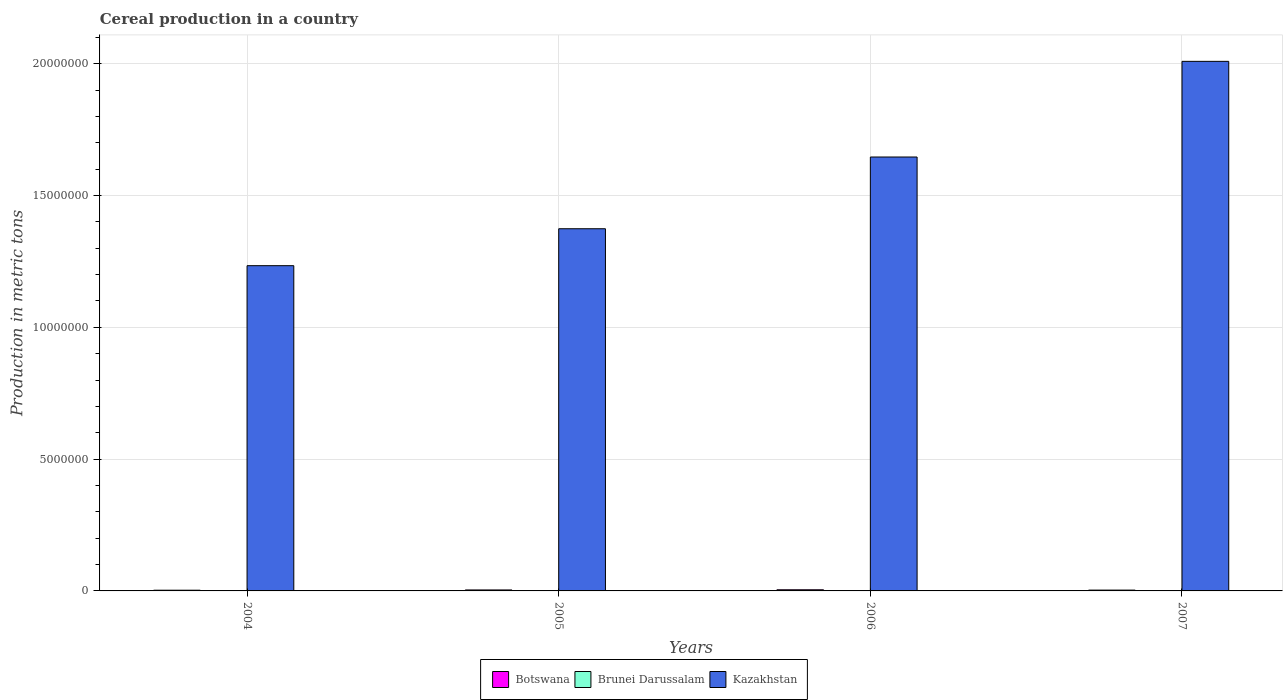How many groups of bars are there?
Keep it short and to the point. 4. Are the number of bars on each tick of the X-axis equal?
Your response must be concise. Yes. How many bars are there on the 2nd tick from the right?
Give a very brief answer. 3. What is the total cereal production in Botswana in 2004?
Keep it short and to the point. 2.67e+04. Across all years, what is the maximum total cereal production in Brunei Darussalam?
Provide a succinct answer. 983. Across all years, what is the minimum total cereal production in Botswana?
Your answer should be compact. 2.67e+04. In which year was the total cereal production in Botswana maximum?
Your response must be concise. 2006. In which year was the total cereal production in Brunei Darussalam minimum?
Your answer should be very brief. 2004. What is the total total cereal production in Kazakhstan in the graph?
Your answer should be very brief. 6.26e+07. What is the difference between the total cereal production in Brunei Darussalam in 2006 and that in 2007?
Offer a terse response. -97. What is the difference between the total cereal production in Kazakhstan in 2005 and the total cereal production in Botswana in 2006?
Keep it short and to the point. 1.37e+07. What is the average total cereal production in Kazakhstan per year?
Offer a very short reply. 1.57e+07. In the year 2007, what is the difference between the total cereal production in Kazakhstan and total cereal production in Brunei Darussalam?
Provide a succinct answer. 2.01e+07. In how many years, is the total cereal production in Botswana greater than 19000000 metric tons?
Make the answer very short. 0. What is the ratio of the total cereal production in Brunei Darussalam in 2004 to that in 2006?
Offer a terse response. 0.7. Is the total cereal production in Kazakhstan in 2006 less than that in 2007?
Offer a terse response. Yes. What is the difference between the highest and the second highest total cereal production in Kazakhstan?
Make the answer very short. 3.63e+06. What is the difference between the highest and the lowest total cereal production in Botswana?
Provide a short and direct response. 1.69e+04. Is the sum of the total cereal production in Brunei Darussalam in 2004 and 2007 greater than the maximum total cereal production in Botswana across all years?
Offer a terse response. No. What does the 2nd bar from the left in 2005 represents?
Your answer should be compact. Brunei Darussalam. What does the 1st bar from the right in 2007 represents?
Provide a short and direct response. Kazakhstan. How many bars are there?
Your answer should be compact. 12. What is the difference between two consecutive major ticks on the Y-axis?
Your answer should be very brief. 5.00e+06. Are the values on the major ticks of Y-axis written in scientific E-notation?
Provide a short and direct response. No. Does the graph contain grids?
Offer a terse response. Yes. How many legend labels are there?
Offer a terse response. 3. What is the title of the graph?
Ensure brevity in your answer.  Cereal production in a country. Does "Low & middle income" appear as one of the legend labels in the graph?
Your answer should be very brief. No. What is the label or title of the Y-axis?
Provide a short and direct response. Production in metric tons. What is the Production in metric tons in Botswana in 2004?
Offer a very short reply. 2.67e+04. What is the Production in metric tons of Brunei Darussalam in 2004?
Keep it short and to the point. 620. What is the Production in metric tons of Kazakhstan in 2004?
Give a very brief answer. 1.23e+07. What is the Production in metric tons in Botswana in 2005?
Your answer should be compact. 3.68e+04. What is the Production in metric tons of Brunei Darussalam in 2005?
Offer a very short reply. 851. What is the Production in metric tons in Kazakhstan in 2005?
Provide a succinct answer. 1.37e+07. What is the Production in metric tons in Botswana in 2006?
Offer a terse response. 4.35e+04. What is the Production in metric tons of Brunei Darussalam in 2006?
Offer a terse response. 886. What is the Production in metric tons in Kazakhstan in 2006?
Keep it short and to the point. 1.65e+07. What is the Production in metric tons in Botswana in 2007?
Keep it short and to the point. 3.13e+04. What is the Production in metric tons of Brunei Darussalam in 2007?
Your response must be concise. 983. What is the Production in metric tons in Kazakhstan in 2007?
Keep it short and to the point. 2.01e+07. Across all years, what is the maximum Production in metric tons of Botswana?
Offer a very short reply. 4.35e+04. Across all years, what is the maximum Production in metric tons of Brunei Darussalam?
Keep it short and to the point. 983. Across all years, what is the maximum Production in metric tons in Kazakhstan?
Your response must be concise. 2.01e+07. Across all years, what is the minimum Production in metric tons of Botswana?
Your response must be concise. 2.67e+04. Across all years, what is the minimum Production in metric tons in Brunei Darussalam?
Offer a very short reply. 620. Across all years, what is the minimum Production in metric tons in Kazakhstan?
Provide a succinct answer. 1.23e+07. What is the total Production in metric tons in Botswana in the graph?
Make the answer very short. 1.38e+05. What is the total Production in metric tons in Brunei Darussalam in the graph?
Offer a very short reply. 3340. What is the total Production in metric tons of Kazakhstan in the graph?
Give a very brief answer. 6.26e+07. What is the difference between the Production in metric tons in Botswana in 2004 and that in 2005?
Ensure brevity in your answer.  -1.02e+04. What is the difference between the Production in metric tons in Brunei Darussalam in 2004 and that in 2005?
Ensure brevity in your answer.  -231. What is the difference between the Production in metric tons of Kazakhstan in 2004 and that in 2005?
Give a very brief answer. -1.40e+06. What is the difference between the Production in metric tons in Botswana in 2004 and that in 2006?
Make the answer very short. -1.69e+04. What is the difference between the Production in metric tons in Brunei Darussalam in 2004 and that in 2006?
Provide a succinct answer. -266. What is the difference between the Production in metric tons of Kazakhstan in 2004 and that in 2006?
Keep it short and to the point. -4.12e+06. What is the difference between the Production in metric tons of Botswana in 2004 and that in 2007?
Make the answer very short. -4644. What is the difference between the Production in metric tons in Brunei Darussalam in 2004 and that in 2007?
Provide a short and direct response. -363. What is the difference between the Production in metric tons in Kazakhstan in 2004 and that in 2007?
Offer a very short reply. -7.75e+06. What is the difference between the Production in metric tons of Botswana in 2005 and that in 2006?
Your answer should be compact. -6691. What is the difference between the Production in metric tons of Brunei Darussalam in 2005 and that in 2006?
Keep it short and to the point. -35. What is the difference between the Production in metric tons in Kazakhstan in 2005 and that in 2006?
Ensure brevity in your answer.  -2.72e+06. What is the difference between the Production in metric tons of Botswana in 2005 and that in 2007?
Offer a very short reply. 5529. What is the difference between the Production in metric tons of Brunei Darussalam in 2005 and that in 2007?
Provide a short and direct response. -132. What is the difference between the Production in metric tons of Kazakhstan in 2005 and that in 2007?
Provide a short and direct response. -6.35e+06. What is the difference between the Production in metric tons of Botswana in 2006 and that in 2007?
Give a very brief answer. 1.22e+04. What is the difference between the Production in metric tons in Brunei Darussalam in 2006 and that in 2007?
Offer a terse response. -97. What is the difference between the Production in metric tons of Kazakhstan in 2006 and that in 2007?
Offer a terse response. -3.63e+06. What is the difference between the Production in metric tons in Botswana in 2004 and the Production in metric tons in Brunei Darussalam in 2005?
Provide a succinct answer. 2.58e+04. What is the difference between the Production in metric tons in Botswana in 2004 and the Production in metric tons in Kazakhstan in 2005?
Ensure brevity in your answer.  -1.37e+07. What is the difference between the Production in metric tons of Brunei Darussalam in 2004 and the Production in metric tons of Kazakhstan in 2005?
Give a very brief answer. -1.37e+07. What is the difference between the Production in metric tons of Botswana in 2004 and the Production in metric tons of Brunei Darussalam in 2006?
Provide a succinct answer. 2.58e+04. What is the difference between the Production in metric tons of Botswana in 2004 and the Production in metric tons of Kazakhstan in 2006?
Provide a succinct answer. -1.64e+07. What is the difference between the Production in metric tons of Brunei Darussalam in 2004 and the Production in metric tons of Kazakhstan in 2006?
Your response must be concise. -1.65e+07. What is the difference between the Production in metric tons in Botswana in 2004 and the Production in metric tons in Brunei Darussalam in 2007?
Give a very brief answer. 2.57e+04. What is the difference between the Production in metric tons of Botswana in 2004 and the Production in metric tons of Kazakhstan in 2007?
Your answer should be compact. -2.01e+07. What is the difference between the Production in metric tons of Brunei Darussalam in 2004 and the Production in metric tons of Kazakhstan in 2007?
Provide a short and direct response. -2.01e+07. What is the difference between the Production in metric tons of Botswana in 2005 and the Production in metric tons of Brunei Darussalam in 2006?
Ensure brevity in your answer.  3.60e+04. What is the difference between the Production in metric tons of Botswana in 2005 and the Production in metric tons of Kazakhstan in 2006?
Your answer should be very brief. -1.64e+07. What is the difference between the Production in metric tons of Brunei Darussalam in 2005 and the Production in metric tons of Kazakhstan in 2006?
Ensure brevity in your answer.  -1.65e+07. What is the difference between the Production in metric tons of Botswana in 2005 and the Production in metric tons of Brunei Darussalam in 2007?
Keep it short and to the point. 3.59e+04. What is the difference between the Production in metric tons in Botswana in 2005 and the Production in metric tons in Kazakhstan in 2007?
Keep it short and to the point. -2.01e+07. What is the difference between the Production in metric tons in Brunei Darussalam in 2005 and the Production in metric tons in Kazakhstan in 2007?
Offer a very short reply. -2.01e+07. What is the difference between the Production in metric tons in Botswana in 2006 and the Production in metric tons in Brunei Darussalam in 2007?
Make the answer very short. 4.25e+04. What is the difference between the Production in metric tons in Botswana in 2006 and the Production in metric tons in Kazakhstan in 2007?
Ensure brevity in your answer.  -2.00e+07. What is the difference between the Production in metric tons in Brunei Darussalam in 2006 and the Production in metric tons in Kazakhstan in 2007?
Your answer should be compact. -2.01e+07. What is the average Production in metric tons of Botswana per year?
Give a very brief answer. 3.46e+04. What is the average Production in metric tons of Brunei Darussalam per year?
Provide a succinct answer. 835. What is the average Production in metric tons of Kazakhstan per year?
Provide a short and direct response. 1.57e+07. In the year 2004, what is the difference between the Production in metric tons in Botswana and Production in metric tons in Brunei Darussalam?
Make the answer very short. 2.60e+04. In the year 2004, what is the difference between the Production in metric tons in Botswana and Production in metric tons in Kazakhstan?
Keep it short and to the point. -1.23e+07. In the year 2004, what is the difference between the Production in metric tons in Brunei Darussalam and Production in metric tons in Kazakhstan?
Give a very brief answer. -1.23e+07. In the year 2005, what is the difference between the Production in metric tons of Botswana and Production in metric tons of Brunei Darussalam?
Provide a succinct answer. 3.60e+04. In the year 2005, what is the difference between the Production in metric tons of Botswana and Production in metric tons of Kazakhstan?
Offer a very short reply. -1.37e+07. In the year 2005, what is the difference between the Production in metric tons in Brunei Darussalam and Production in metric tons in Kazakhstan?
Provide a short and direct response. -1.37e+07. In the year 2006, what is the difference between the Production in metric tons in Botswana and Production in metric tons in Brunei Darussalam?
Provide a succinct answer. 4.26e+04. In the year 2006, what is the difference between the Production in metric tons of Botswana and Production in metric tons of Kazakhstan?
Your answer should be very brief. -1.64e+07. In the year 2006, what is the difference between the Production in metric tons of Brunei Darussalam and Production in metric tons of Kazakhstan?
Give a very brief answer. -1.65e+07. In the year 2007, what is the difference between the Production in metric tons in Botswana and Production in metric tons in Brunei Darussalam?
Your answer should be compact. 3.03e+04. In the year 2007, what is the difference between the Production in metric tons of Botswana and Production in metric tons of Kazakhstan?
Provide a succinct answer. -2.01e+07. In the year 2007, what is the difference between the Production in metric tons of Brunei Darussalam and Production in metric tons of Kazakhstan?
Give a very brief answer. -2.01e+07. What is the ratio of the Production in metric tons in Botswana in 2004 to that in 2005?
Give a very brief answer. 0.72. What is the ratio of the Production in metric tons of Brunei Darussalam in 2004 to that in 2005?
Give a very brief answer. 0.73. What is the ratio of the Production in metric tons of Kazakhstan in 2004 to that in 2005?
Provide a short and direct response. 0.9. What is the ratio of the Production in metric tons in Botswana in 2004 to that in 2006?
Your answer should be very brief. 0.61. What is the ratio of the Production in metric tons in Brunei Darussalam in 2004 to that in 2006?
Your answer should be very brief. 0.7. What is the ratio of the Production in metric tons in Kazakhstan in 2004 to that in 2006?
Provide a succinct answer. 0.75. What is the ratio of the Production in metric tons of Botswana in 2004 to that in 2007?
Your response must be concise. 0.85. What is the ratio of the Production in metric tons of Brunei Darussalam in 2004 to that in 2007?
Make the answer very short. 0.63. What is the ratio of the Production in metric tons of Kazakhstan in 2004 to that in 2007?
Offer a terse response. 0.61. What is the ratio of the Production in metric tons of Botswana in 2005 to that in 2006?
Provide a short and direct response. 0.85. What is the ratio of the Production in metric tons in Brunei Darussalam in 2005 to that in 2006?
Ensure brevity in your answer.  0.96. What is the ratio of the Production in metric tons of Kazakhstan in 2005 to that in 2006?
Make the answer very short. 0.83. What is the ratio of the Production in metric tons of Botswana in 2005 to that in 2007?
Your response must be concise. 1.18. What is the ratio of the Production in metric tons in Brunei Darussalam in 2005 to that in 2007?
Provide a succinct answer. 0.87. What is the ratio of the Production in metric tons of Kazakhstan in 2005 to that in 2007?
Ensure brevity in your answer.  0.68. What is the ratio of the Production in metric tons of Botswana in 2006 to that in 2007?
Your answer should be very brief. 1.39. What is the ratio of the Production in metric tons in Brunei Darussalam in 2006 to that in 2007?
Provide a succinct answer. 0.9. What is the ratio of the Production in metric tons in Kazakhstan in 2006 to that in 2007?
Make the answer very short. 0.82. What is the difference between the highest and the second highest Production in metric tons in Botswana?
Your response must be concise. 6691. What is the difference between the highest and the second highest Production in metric tons of Brunei Darussalam?
Make the answer very short. 97. What is the difference between the highest and the second highest Production in metric tons in Kazakhstan?
Your answer should be compact. 3.63e+06. What is the difference between the highest and the lowest Production in metric tons in Botswana?
Your answer should be compact. 1.69e+04. What is the difference between the highest and the lowest Production in metric tons in Brunei Darussalam?
Provide a short and direct response. 363. What is the difference between the highest and the lowest Production in metric tons in Kazakhstan?
Your answer should be compact. 7.75e+06. 